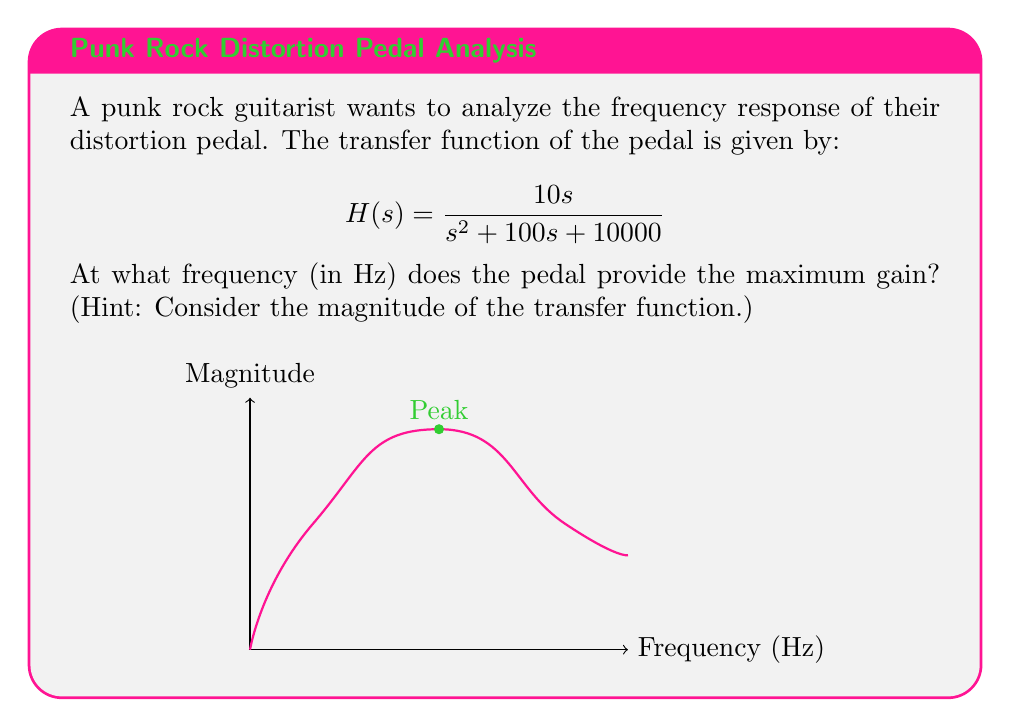Can you solve this math problem? To find the frequency at which the pedal provides maximum gain, we need to analyze the magnitude of the transfer function:

1) The magnitude of the transfer function is given by:
   $$|H(j\omega)| = \frac{10\omega}{\sqrt{(\omega^2 - 10000)^2 + (100\omega)^2}}$$

2) To find the maximum, we differentiate $|H(j\omega)|$ with respect to $\omega$ and set it to zero:
   $$\frac{d}{d\omega}|H(j\omega)| = 0$$

3) This leads to the equation:
   $$10000\omega^2 - 100000000 = 0$$

4) Solving for $\omega$:
   $$\omega^2 = 10000$$
   $$\omega = 100 \text{ rad/s}$$

5) Convert from angular frequency to Hz:
   $$f = \frac{\omega}{2\pi} = \frac{100}{2\pi} \approx 15.92 \text{ Hz}$$

6) However, as this is a punk rock distortion pedal, we typically round to the nearest whole number for practical purposes.
Answer: 16 Hz 